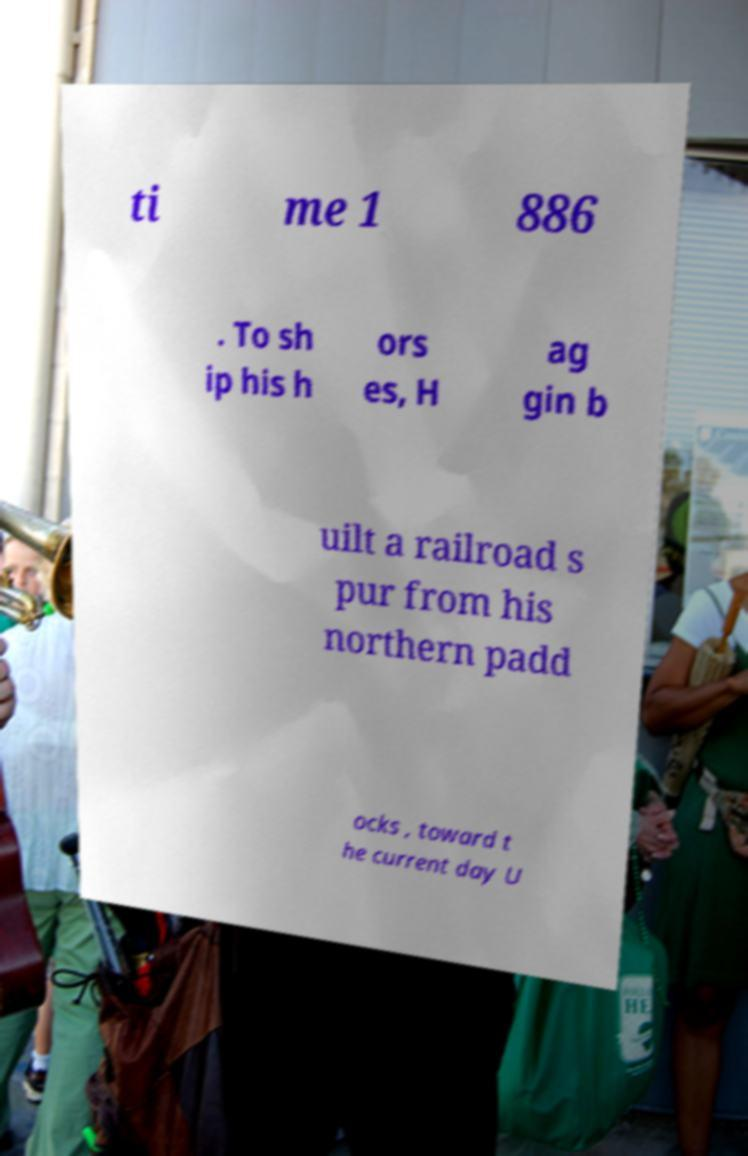There's text embedded in this image that I need extracted. Can you transcribe it verbatim? ti me 1 886 . To sh ip his h ors es, H ag gin b uilt a railroad s pur from his northern padd ocks , toward t he current day U 